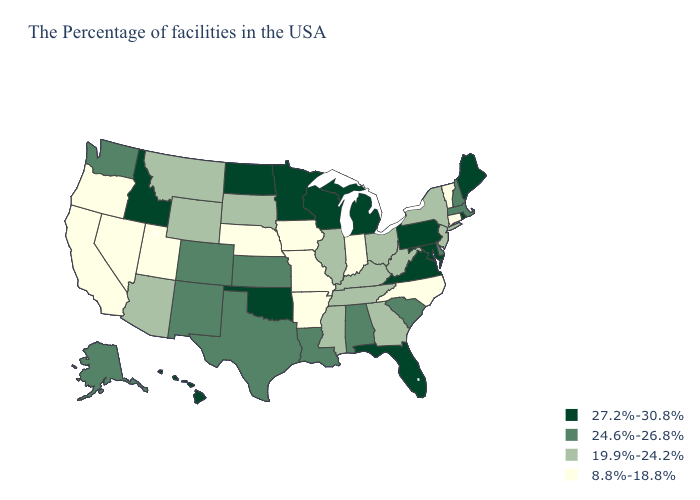What is the value of Indiana?
Give a very brief answer. 8.8%-18.8%. What is the value of Wisconsin?
Answer briefly. 27.2%-30.8%. Which states hav the highest value in the South?
Write a very short answer. Maryland, Virginia, Florida, Oklahoma. What is the lowest value in states that border Louisiana?
Write a very short answer. 8.8%-18.8%. Does the first symbol in the legend represent the smallest category?
Short answer required. No. What is the lowest value in the South?
Be succinct. 8.8%-18.8%. Does Arkansas have the lowest value in the USA?
Give a very brief answer. Yes. Is the legend a continuous bar?
Give a very brief answer. No. Which states have the lowest value in the USA?
Quick response, please. Vermont, Connecticut, North Carolina, Indiana, Missouri, Arkansas, Iowa, Nebraska, Utah, Nevada, California, Oregon. What is the value of Indiana?
Write a very short answer. 8.8%-18.8%. Is the legend a continuous bar?
Write a very short answer. No. Name the states that have a value in the range 24.6%-26.8%?
Write a very short answer. Massachusetts, New Hampshire, Delaware, South Carolina, Alabama, Louisiana, Kansas, Texas, Colorado, New Mexico, Washington, Alaska. Is the legend a continuous bar?
Give a very brief answer. No. Which states have the lowest value in the USA?
Be succinct. Vermont, Connecticut, North Carolina, Indiana, Missouri, Arkansas, Iowa, Nebraska, Utah, Nevada, California, Oregon. Name the states that have a value in the range 27.2%-30.8%?
Answer briefly. Maine, Rhode Island, Maryland, Pennsylvania, Virginia, Florida, Michigan, Wisconsin, Minnesota, Oklahoma, North Dakota, Idaho, Hawaii. 